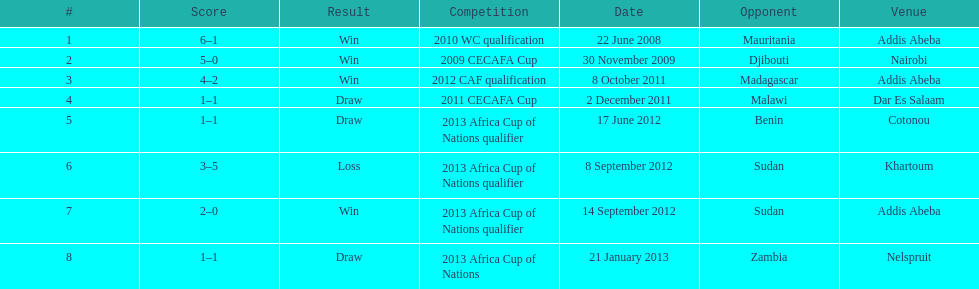What date corresponds to their single setback? 8 September 2012. 